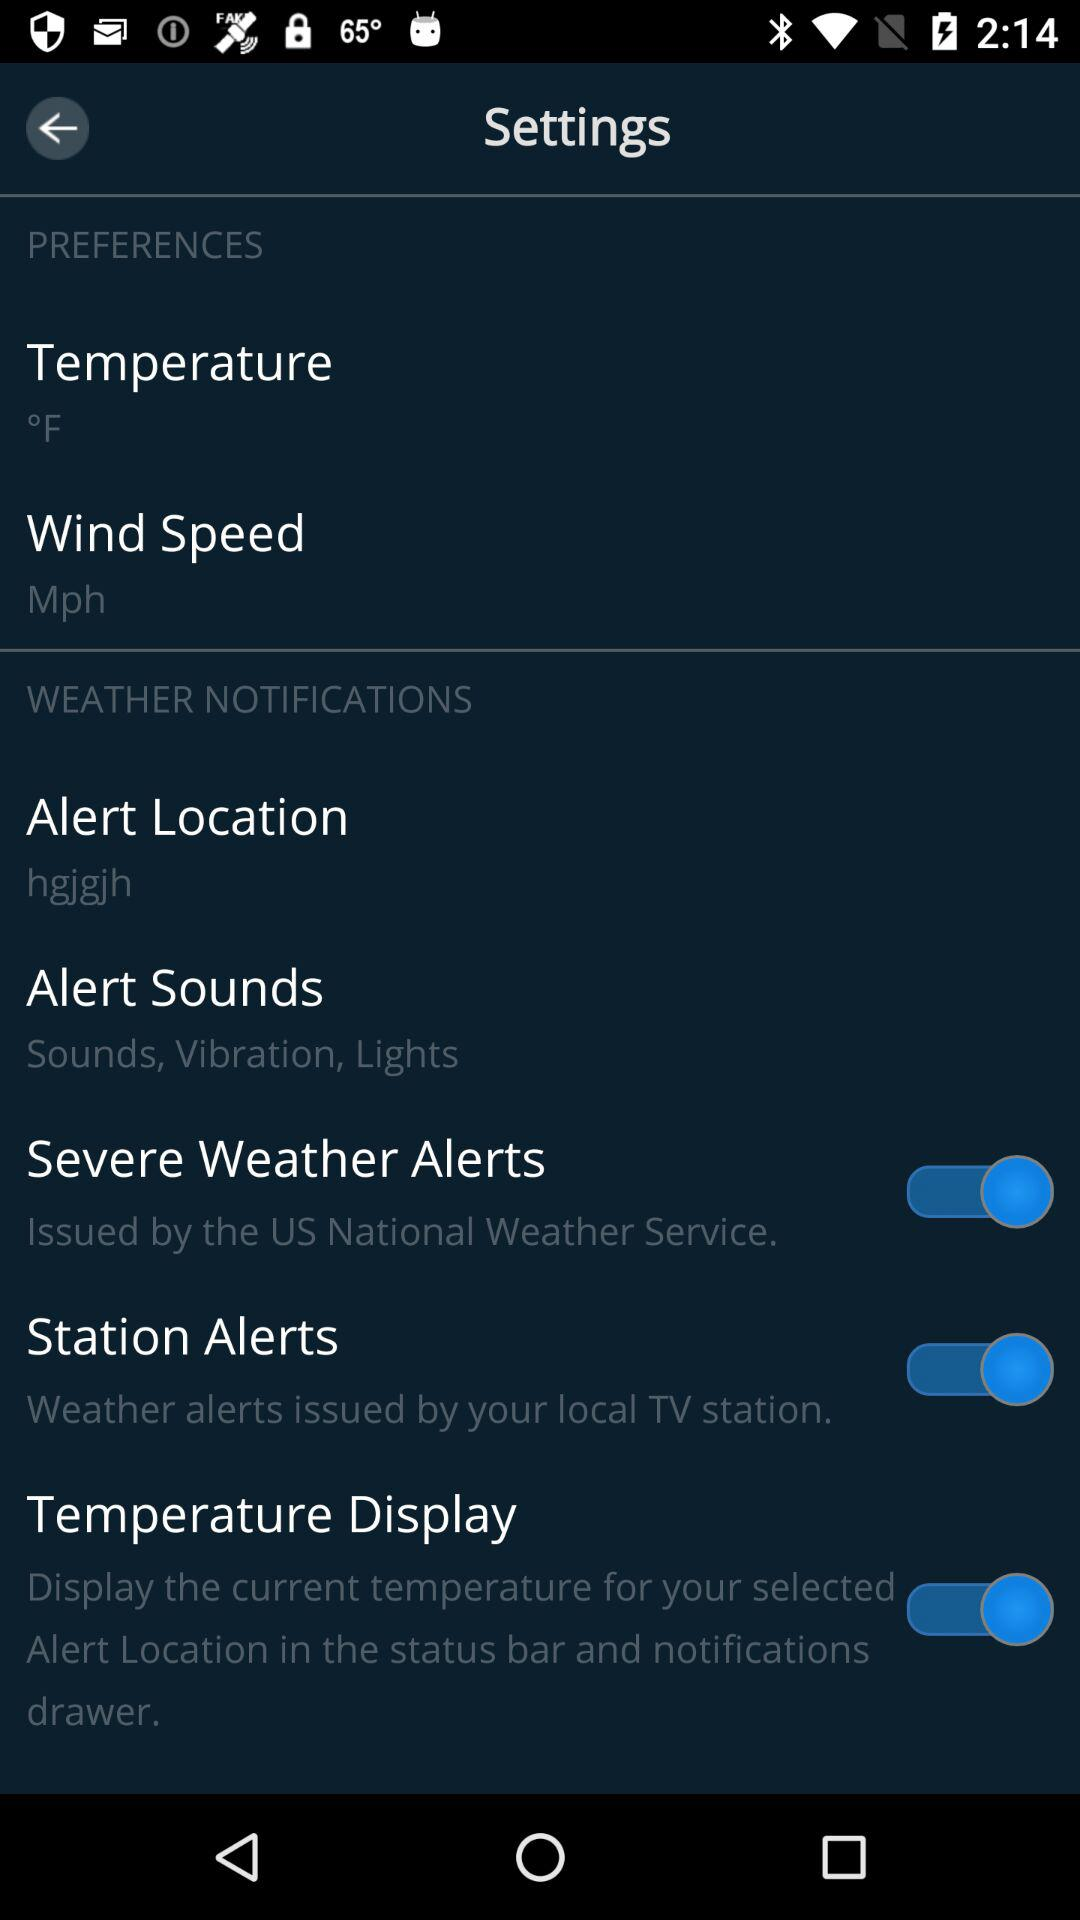How many more items are in the Weather Notifications section than the Preferences section?
Answer the question using a single word or phrase. 3 